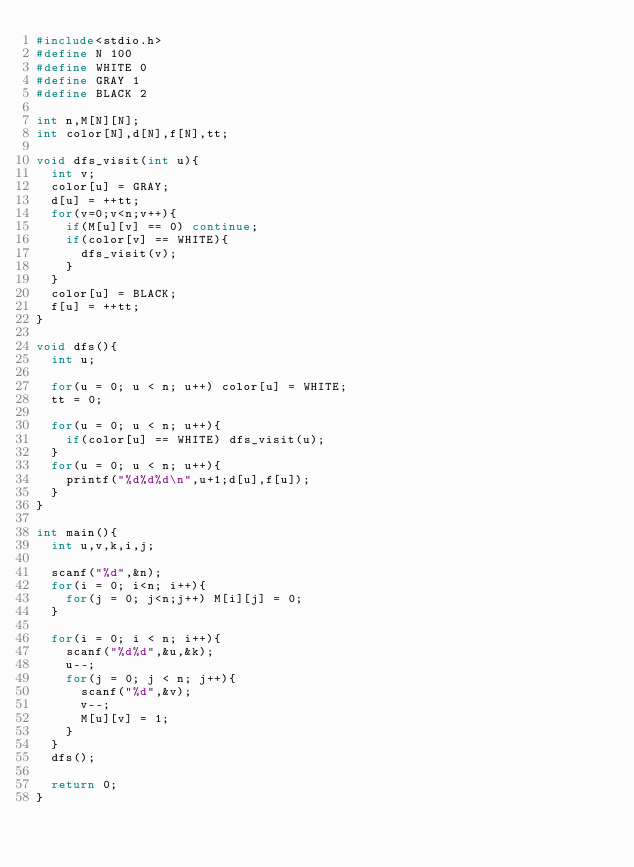Convert code to text. <code><loc_0><loc_0><loc_500><loc_500><_C_>#include<stdio.h>
#define N 100
#define WHITE 0
#define GRAY 1
#define BLACK 2

int n,M[N][N];
int color[N],d[N],f[N],tt;

void dfs_visit(int u){
  int v;
  color[u] = GRAY;
  d[u] = ++tt;
  for(v=0;v<n;v++){
    if(M[u][v] == 0) continue;
    if(color[v] == WHITE){
      dfs_visit(v);
    }
  }
  color[u] = BLACK;
  f[u] = ++tt;
}

void dfs(){
  int u;

  for(u = 0; u < n; u++) color[u] = WHITE;
  tt = 0;

  for(u = 0; u < n; u++){
    if(color[u] == WHITE) dfs_visit(u);
  }
  for(u = 0; u < n; u++){
    printf("%d%d%d\n",u+1;d[u],f[u]);
  }
}

int main(){
  int u,v,k,i,j;

  scanf("%d",&n);
  for(i = 0; i<n; i++){
    for(j = 0; j<n;j++) M[i][j] = 0;
  }

  for(i = 0; i < n; i++){
    scanf("%d%d",&u,&k);
    u--;
    for(j = 0; j < n; j++){
      scanf("%d",&v);
      v--;
      M[u][v] = 1;
    }
  }
  dfs();

  return 0;
}

</code> 